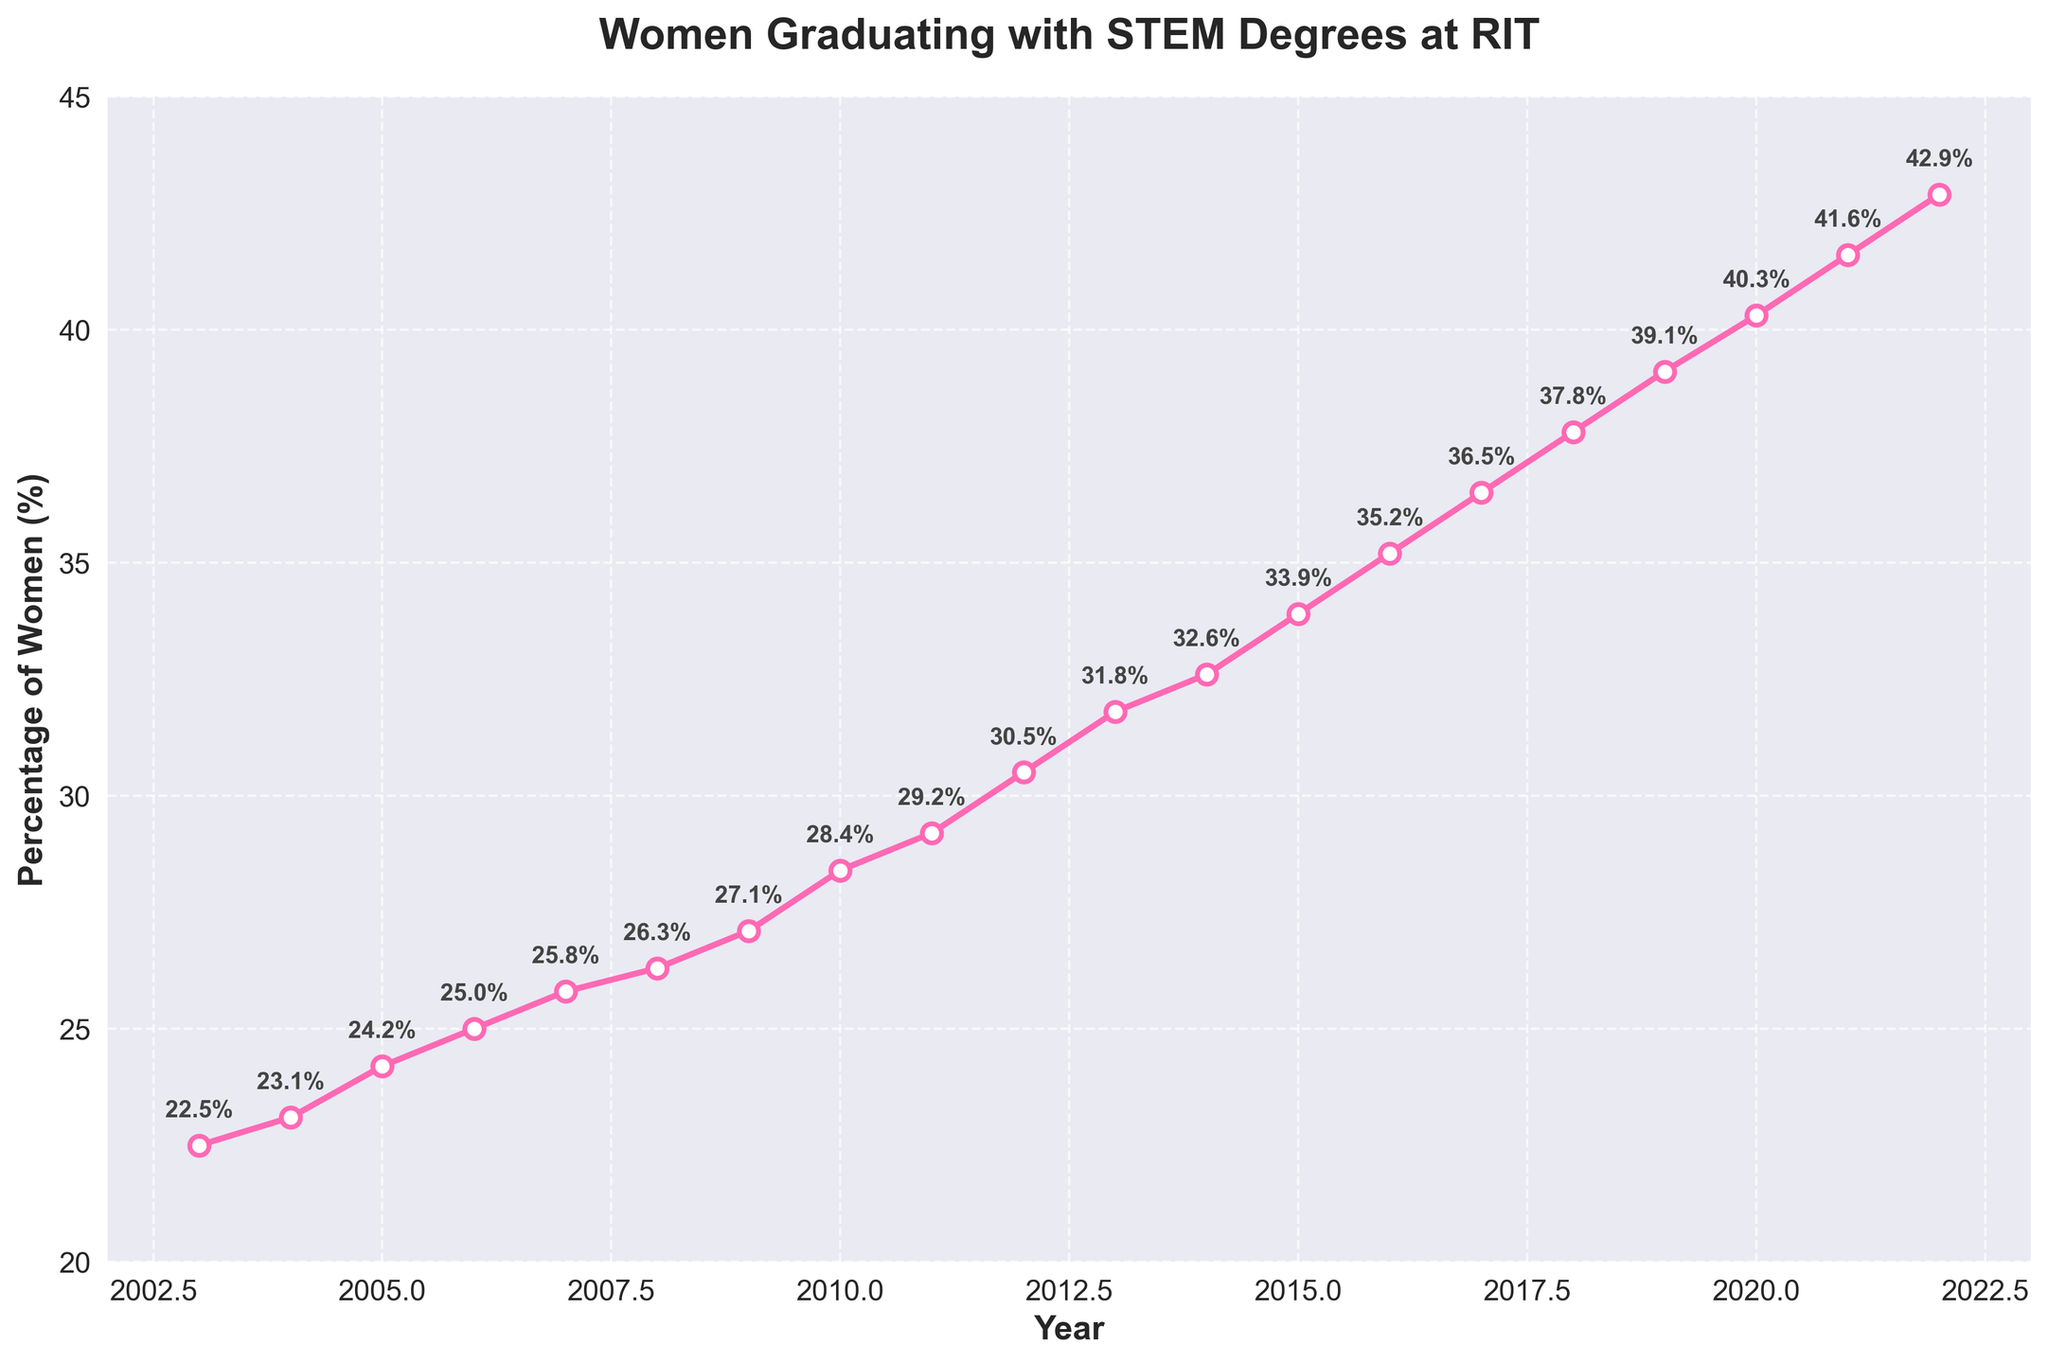What's the percentage of women graduating with STEM degrees at RIT in 2008? The position on the x-axis that corresponds to the year 2008 intersects the line chart at a specific y-axis value. Looking at this intersection point, the labeled percentage is 26.3%.
Answer: 26.3% How much did the percentage of women graduating with STEM degrees increase from 2003 to 2022? To find the increase, subtract the percentage in 2003 from the percentage in 2022. The percentage in 2022 is 42.9%, and the percentage in 2003 is 22.5%. So, 42.9% - 22.5% = 20.4%.
Answer: 20.4% Between which consecutive years was the greatest increase in the percentage of women graduating observed? To determine this, compare the increases between each consecutive pair of years. The greatest increase is between 2018 and 2019, where the percentage rose from 37.8% to 39.1%, an increase of 1.3%.
Answer: 2018-2019 What is the average percentage of women graduating with STEM degrees from 2010 to 2020? First, find the percentages for each year from 2010 to 2020: [28.4, 29.2, 30.5, 31.8, 32.6, 33.9, 35.2, 36.5, 37.8, 39.1, 40.3]. Sum these values and divide by the number of years. The sum is 375.3 and there are 11 years, so the average is 375.3 / 11 ≈ 34.11%.
Answer: 34.11% Which year saw the lowest percentage of graduating women in STEM, and what was the percentage? The lowest value on the graph occurs at the start, in 2003, with the percentage being 22.5%.
Answer: 2003, 22.5% Compare the percentage increase of women graduating from 2010 to 2011 with the increase from 2021 to 2022. Which was greater? For 2010 to 2011, the increase is 29.2% - 28.4% = 0.8%. For 2021 to 2022, the increase is 42.9% - 41.6% = 1.3%. The increase from 2021 to 2022 is greater than from 2010 to 2011.
Answer: 2021 to 2022 What is the trend shown in the graph for the percentage of women graduating with STEM degrees at RIT? The trend is upward, showing a continuous increase in the percentage of women graduating with STEM degrees over the 20-year period from 2003 to 2022.
Answer: Upward trend By what percentage did the female STEM graduation rate grow on average per year between 2003 and 2022? To find the average annual growth, subtract the starting percentage (22.5% in 2003) from the ending percentage (42.9% in 2022) to get 20.4%. Then, divide by the number of years (2022 - 2003 = 19 years). So, 20.4% / 19 ≈ 1.07%.
Answer: 1.07% 